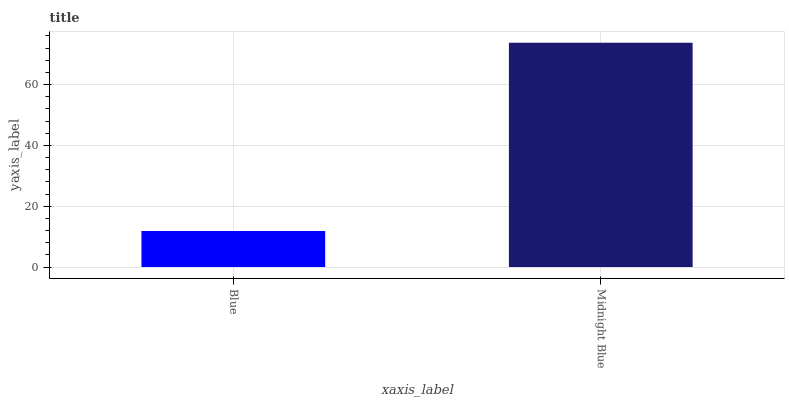Is Midnight Blue the minimum?
Answer yes or no. No. Is Midnight Blue greater than Blue?
Answer yes or no. Yes. Is Blue less than Midnight Blue?
Answer yes or no. Yes. Is Blue greater than Midnight Blue?
Answer yes or no. No. Is Midnight Blue less than Blue?
Answer yes or no. No. Is Midnight Blue the high median?
Answer yes or no. Yes. Is Blue the low median?
Answer yes or no. Yes. Is Blue the high median?
Answer yes or no. No. Is Midnight Blue the low median?
Answer yes or no. No. 